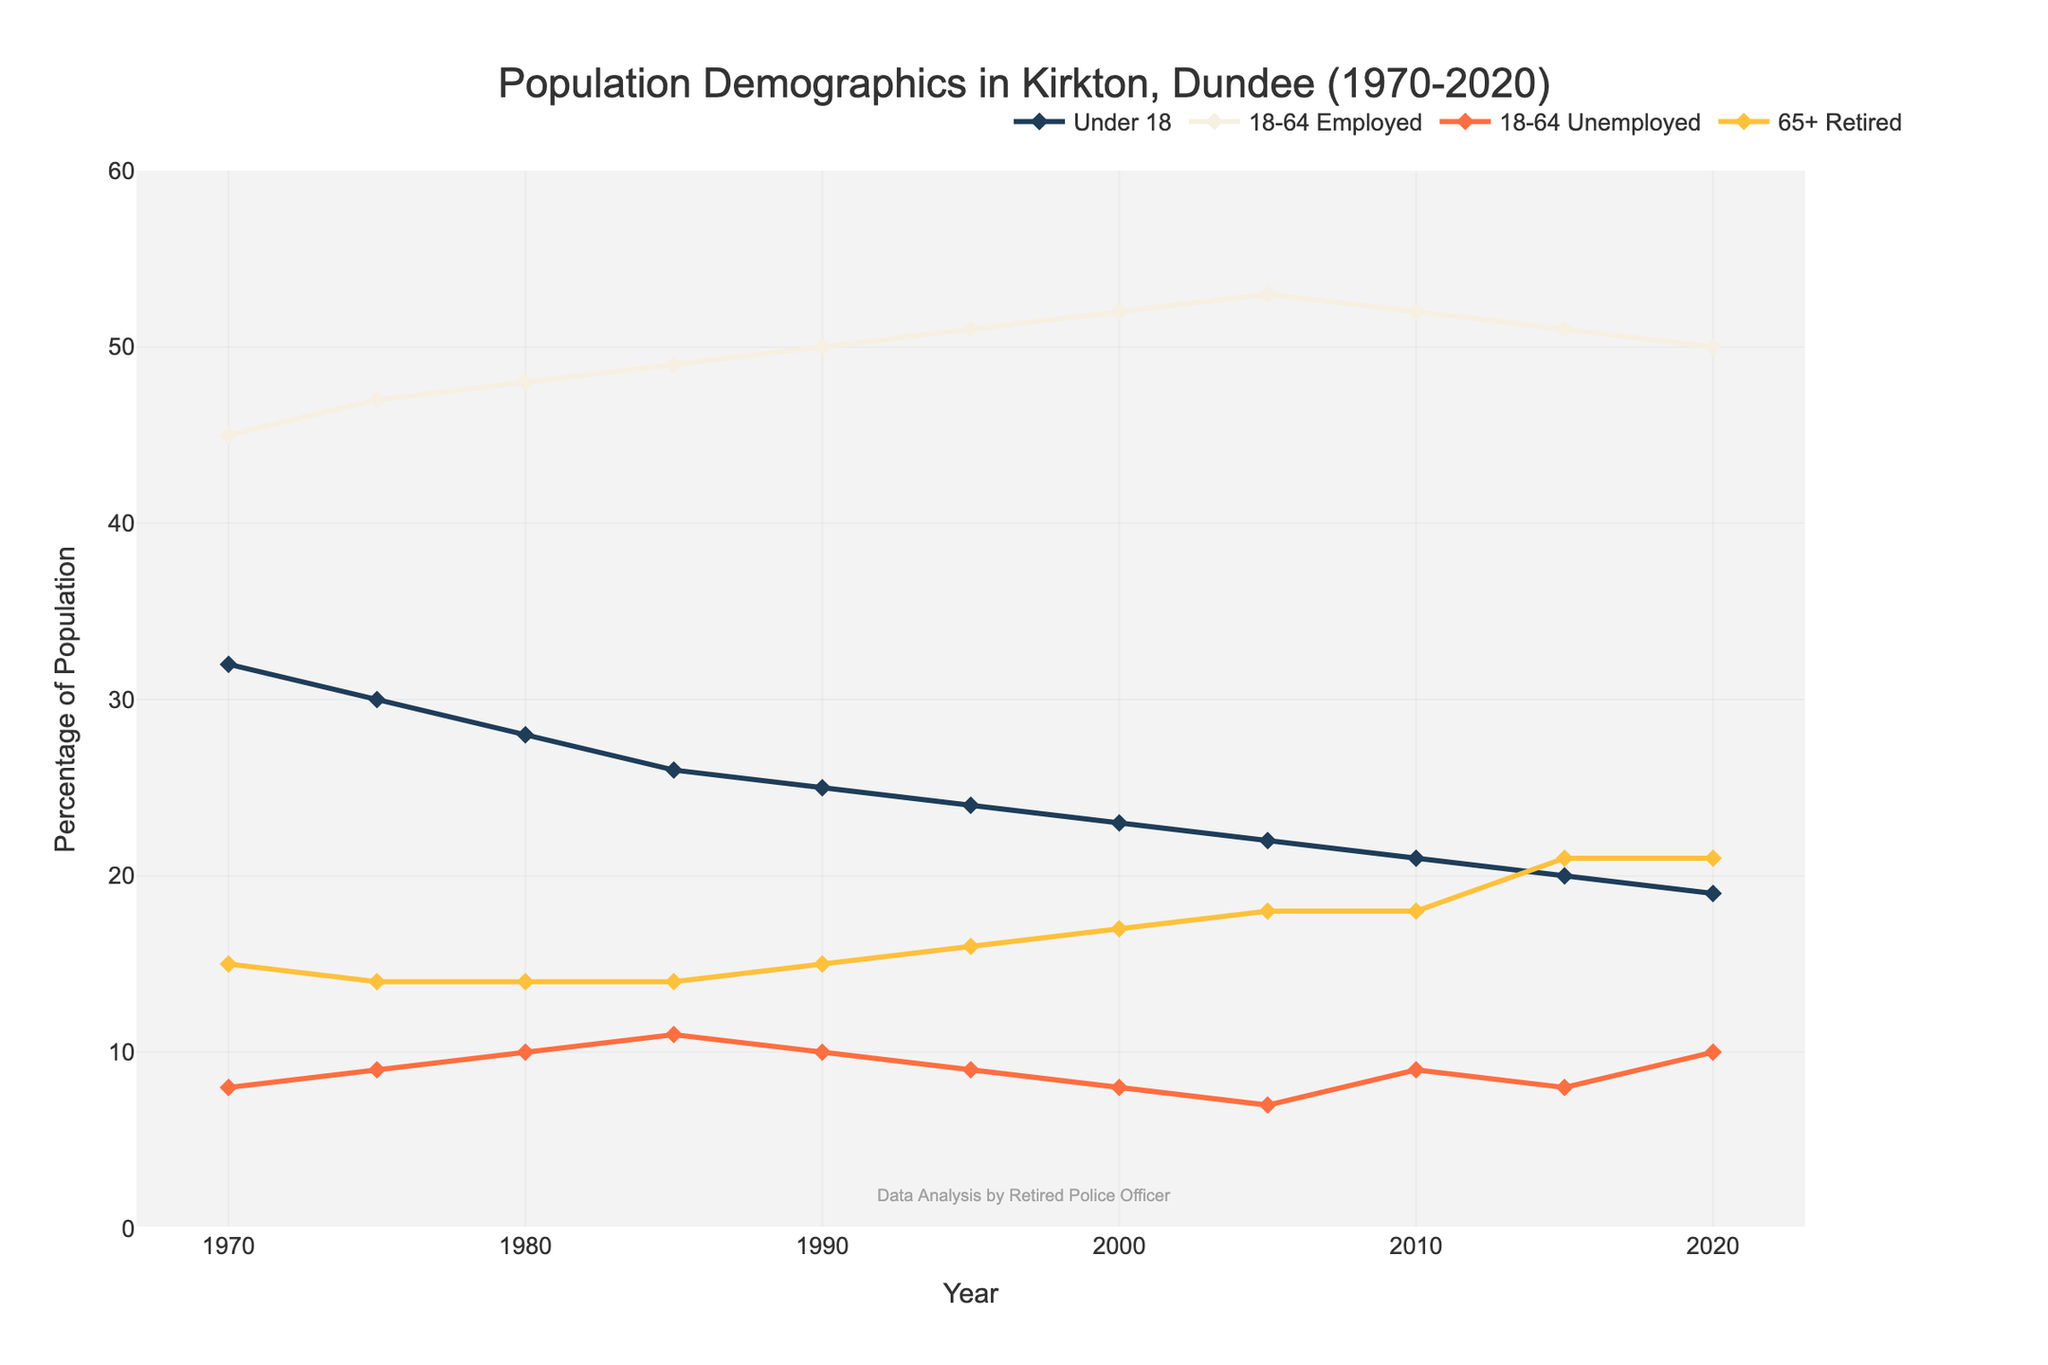What is the trend in the percentage of the Under 18 age group from 1970 to 2020? The trend in the percentage of the Under 18 age group shows a decrease from 32% in 1970 to 19% in 2020. This trend can be observed by noting the declining position of the line representing the Under 18 age group on the chart over the years.
Answer: Decreasing How does the percentage of 18-64 Employed change between 1970 to 2020? The percentage of the 18-64 Employed group increases from 45% in 1970 to 50% in 2020. This increase can be confirmed by following the line representing 18-64 Employed on the plot, noting the overall upward trend.
Answer: Increasing Which year has the highest percentage for the 18-64 Unemployed group, and what is the percentage? The highest percentage for the 18-64 Unemployed group occurs in 1985 with 11%. This is identified by locating the peak point on the line representing the 18-64 Unemployed group.
Answer: 1985, 11% Compare the percentage of the 65+ Retired group in 1970 and 2020. What is the difference? In 1970, the percentage of the 65+ Retired group is 15%, and in 2020, it is 21%. The difference is calculated by subtracting the earlier value from the later one: 21% - 15% = 6%.
Answer: 6% What is the average percentage of the 18-64 Employed group over the five decades depicted? The values for the 18-64 Employed group are [45, 47, 48, 49, 50, 51, 52, 53, 52, 51, 50]. The sum of these values is 548. The number of data points is 11. The average percentage is calculated as 548 / 11 ≈ 49.82%.
Answer: 49.82% Which age group experiences the most noticeable change in percentage from 1970 to 2020? By comparing all age groups, the Under 18 group has a significant decline, from 32% in 1970 to 19% in 2020, which is a 13% decrease. No other group shows such a drastic change over the period.
Answer: Under 18 In which year does the percentage of the Under 18 group equal the percentage of the 65+ Retired group? In 2015, both the Under 18 and 65+ Retired groups are at 20% and 21%, respectively. Contextually, they are the closest in this year.
Answer: 2015 In which range of years does the percentage of 18-64 Employed remain above 50%? The percentage of 18-64 Employed exceeds 50% from the year 1990 to 2015. This is observed by identifying the range where the line for the 18-64 Employed group remains above the 50% mark on the y-axis.
Answer: 1990 to 2015 What is the percentage difference between 18-64 Employed and Unemployed in 2000? In 2000, the percentage for 18-64 Employed is 52% and for Unemployed is 8%. The difference is calculated as 52% - 8% = 44%.
Answer: 44% How has the percentage of 65+ Retired changed between 1970 and 2005? The percentage for 65+ Retired increases from 15% in 1970 to 18% in 2005. This change corresponds to an increase of 18% - 15% = 3%.
Answer: 3% 